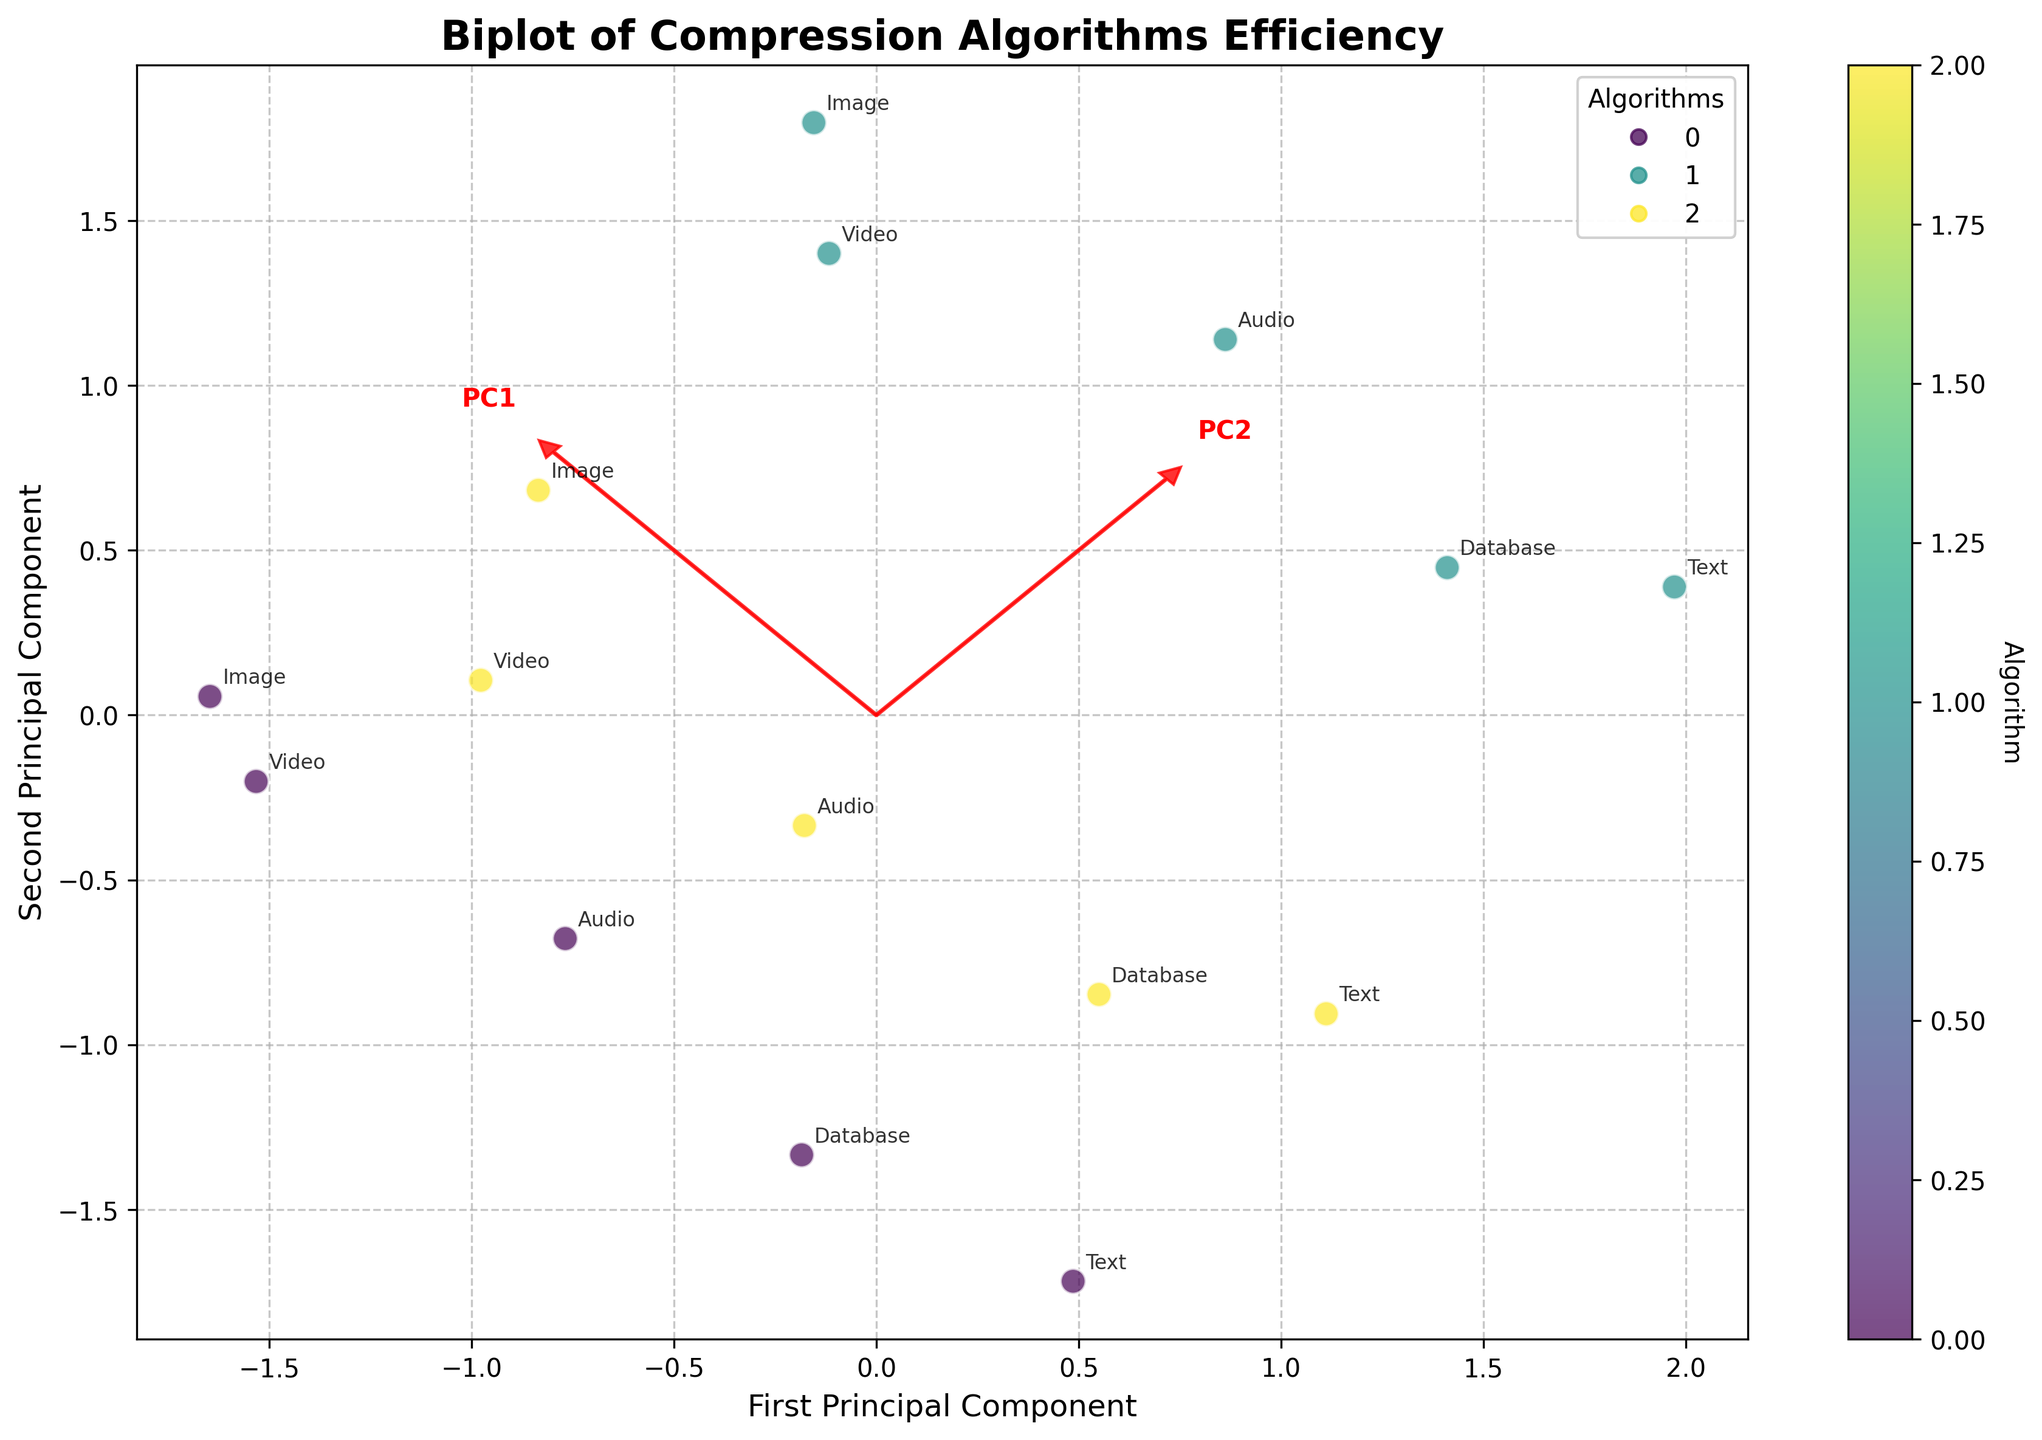What is the title of the plot? The title of a plot is usually located at the top-centre part of the figure. In this case, it can be read directly from the plot.
Answer: Biplot of Compression Algorithms Efficiency How many different algorithms are represented in the plot? Look at the legend or the colors on the scatter points; each color represents a unique algorithm. There are three distinct colors, hence three algorithms are represented.
Answer: 3 Which file type is closest to the first principal component axis? By observing the points plotted along the first principal component (x-axis), identify which labeled point is nearest to this axis.
Answer: Image Which algorithm shows the highest variation in the plot? Identify the colored scatter points that are most spread across the plot. GZIP shows the widest distribution in both principal components suggesting higher variation.
Answer: GZIP What are the eigenvalues represented by the arrows? The arrows are scaled by the eigenvalues of each principal component. Check the lengths and labels of the arrows to determine the eigenvalues.
Answer: PC1 and PC2 Which file type shows the least variation in the second principal component? Examine the distances of points in the second principal component (y-axis). The file type whose points are most horizontally aligned has the least variation.
Answer: Video What can you infer about the relationship between CompressionRatio and ProcessingSpeed for different algorithms? Since PCA combines these features, observe the positions of the same-colored points (representing each algorithm) to infer their relationships.
Answer: Complex, depends on the algorithm Compare the position of the Text file type with Video file type for the GZIP algorithm. Identify the positions of the labeled points for 'Text' and 'Video' under the same color (GZIP). Compare their coordinates on both principal components.
Answer: Text is more negative on PC1 Which principal component explains more variance in the data? Considering the lengths of the vectors pointing towards PC1 and PC2, infer which has a higher eigenvalue. PC1 vector is longer, so PC1 explains more variance.
Answer: PC1 If you were to add a new file type that behaves like Text in terms of CompressionRatio and ProcessingSpeed for each algorithm, where would it likely appear? Comparing the positions and spreads of points labeled ‘Text’ for each algorithm, the new file type would likely appear near these points consistently.
Answer: Near Text points How do GZIP, LZMA, and Bzip2 algorithms compare in terms of processing speed as observed from the plot? By comparing the spread of points for each algorithm color along the second principal component (indicative of ProcessingSpeed), infer the relative speeds.
Answer: GZIP > LZMA > Bzip2 